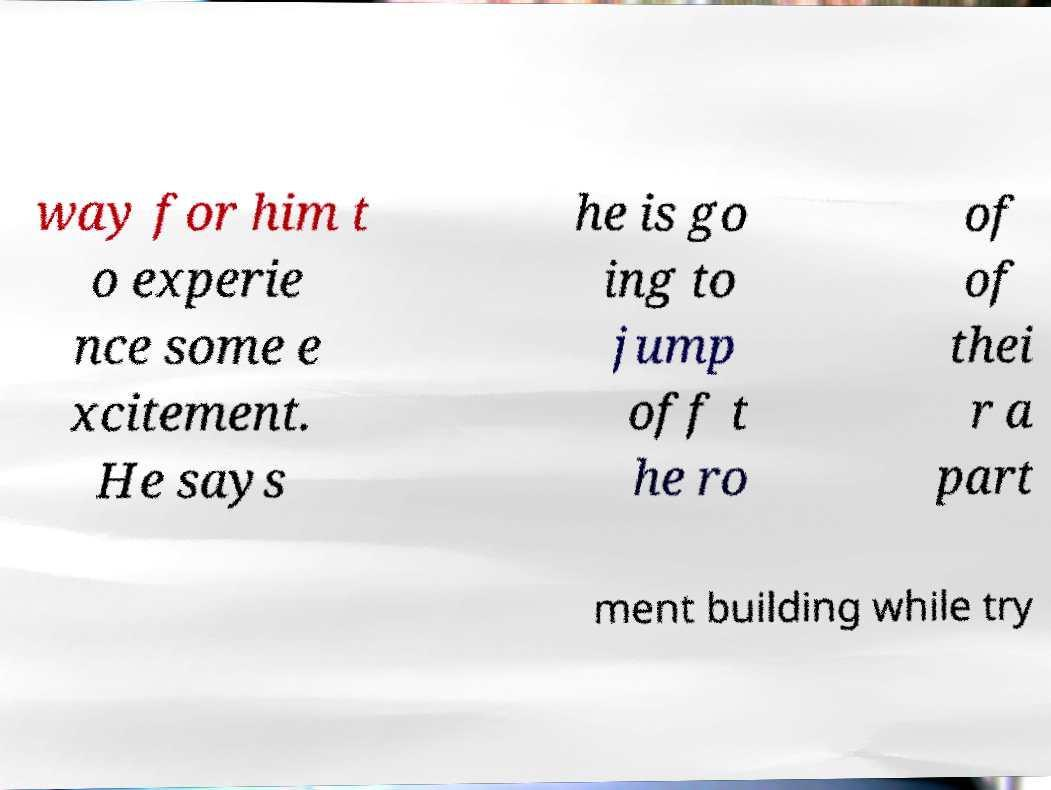Please identify and transcribe the text found in this image. way for him t o experie nce some e xcitement. He says he is go ing to jump off t he ro of of thei r a part ment building while try 